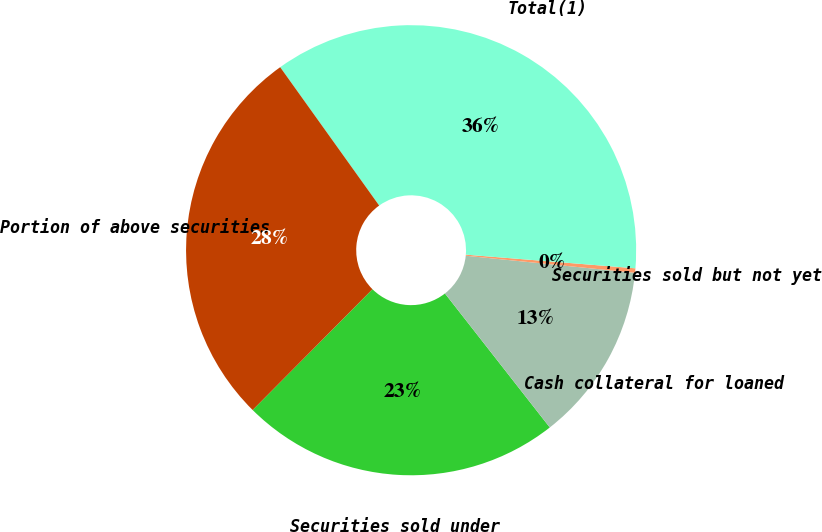Convert chart. <chart><loc_0><loc_0><loc_500><loc_500><pie_chart><fcel>Securities sold under<fcel>Cash collateral for loaned<fcel>Securities sold but not yet<fcel>Total(1)<fcel>Portion of above securities<nl><fcel>23.0%<fcel>12.83%<fcel>0.32%<fcel>36.16%<fcel>27.68%<nl></chart> 